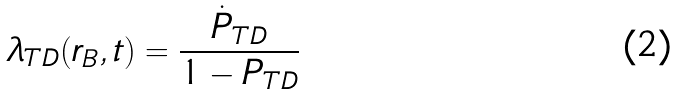Convert formula to latex. <formula><loc_0><loc_0><loc_500><loc_500>\lambda _ { T D } ( r _ { B } , t ) = \frac { \dot { P } _ { T D } } { 1 - P _ { T D } }</formula> 